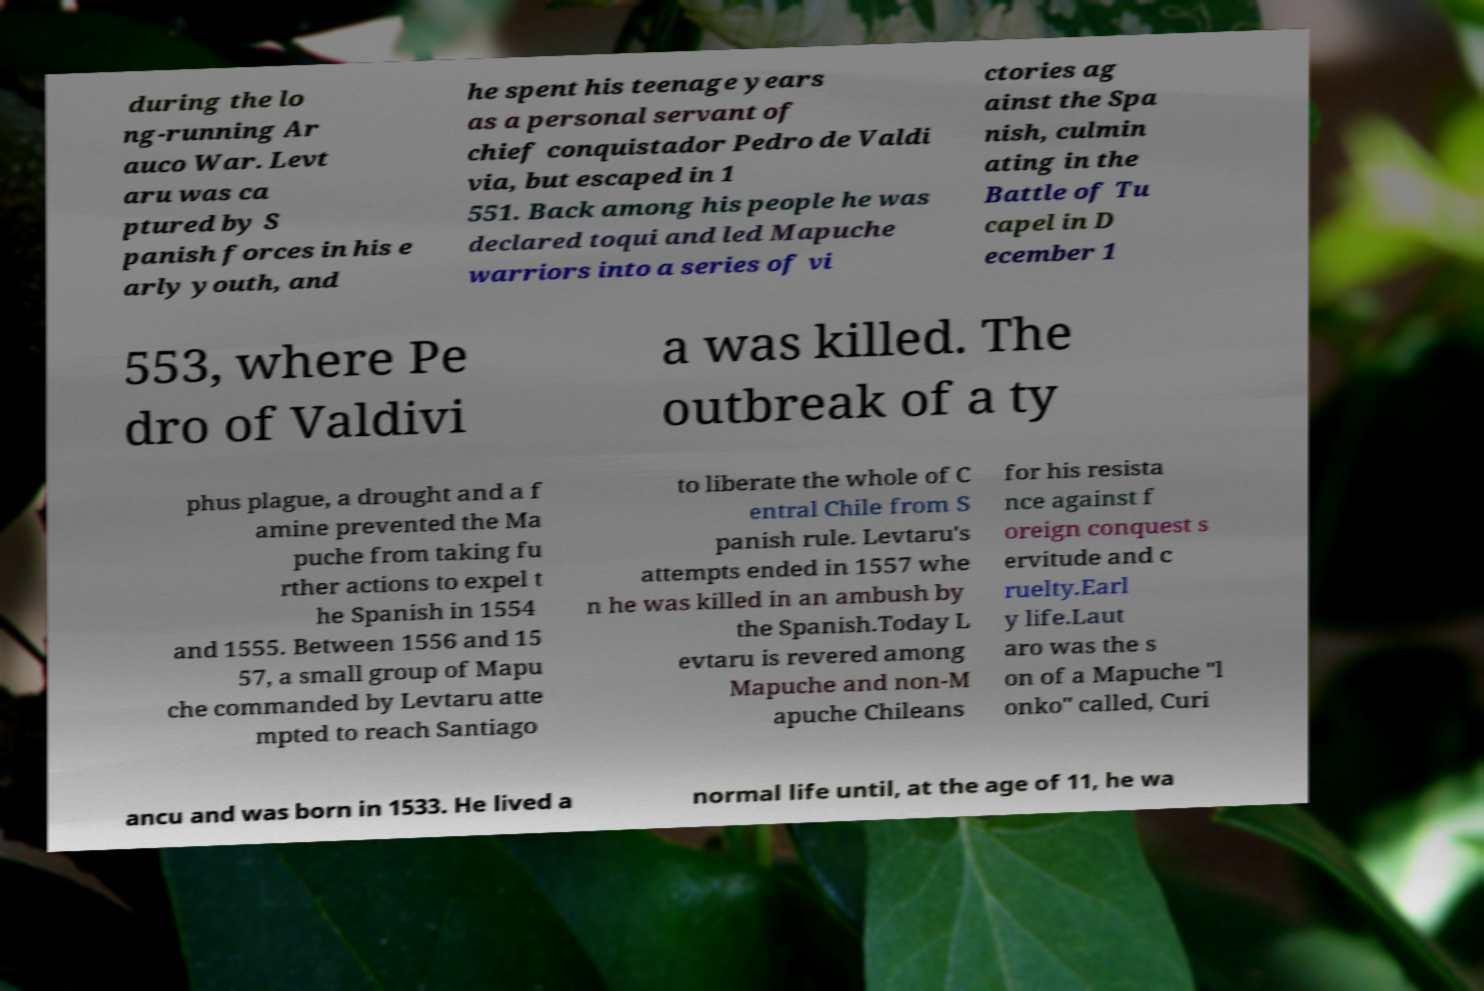Could you assist in decoding the text presented in this image and type it out clearly? during the lo ng-running Ar auco War. Levt aru was ca ptured by S panish forces in his e arly youth, and he spent his teenage years as a personal servant of chief conquistador Pedro de Valdi via, but escaped in 1 551. Back among his people he was declared toqui and led Mapuche warriors into a series of vi ctories ag ainst the Spa nish, culmin ating in the Battle of Tu capel in D ecember 1 553, where Pe dro of Valdivi a was killed. The outbreak of a ty phus plague, a drought and a f amine prevented the Ma puche from taking fu rther actions to expel t he Spanish in 1554 and 1555. Between 1556 and 15 57, a small group of Mapu che commanded by Levtaru atte mpted to reach Santiago to liberate the whole of C entral Chile from S panish rule. Levtaru's attempts ended in 1557 whe n he was killed in an ambush by the Spanish.Today L evtaru is revered among Mapuche and non-M apuche Chileans for his resista nce against f oreign conquest s ervitude and c ruelty.Earl y life.Laut aro was the s on of a Mapuche "l onko" called, Curi ancu and was born in 1533. He lived a normal life until, at the age of 11, he wa 